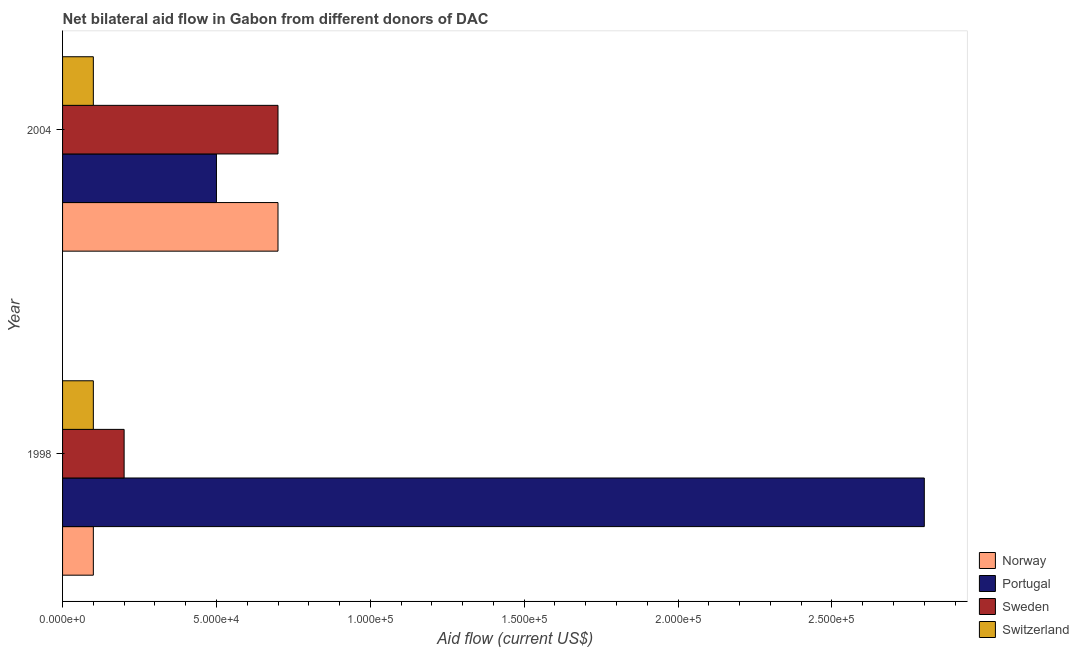How many different coloured bars are there?
Keep it short and to the point. 4. How many groups of bars are there?
Provide a short and direct response. 2. How many bars are there on the 1st tick from the top?
Your answer should be very brief. 4. What is the label of the 1st group of bars from the top?
Keep it short and to the point. 2004. In how many cases, is the number of bars for a given year not equal to the number of legend labels?
Provide a succinct answer. 0. What is the amount of aid given by portugal in 1998?
Make the answer very short. 2.80e+05. Across all years, what is the maximum amount of aid given by portugal?
Provide a succinct answer. 2.80e+05. Across all years, what is the minimum amount of aid given by sweden?
Your response must be concise. 2.00e+04. In which year was the amount of aid given by norway maximum?
Your response must be concise. 2004. What is the total amount of aid given by sweden in the graph?
Your answer should be very brief. 9.00e+04. What is the difference between the amount of aid given by sweden in 1998 and that in 2004?
Offer a terse response. -5.00e+04. What is the difference between the amount of aid given by portugal in 2004 and the amount of aid given by switzerland in 1998?
Provide a succinct answer. 4.00e+04. What is the average amount of aid given by sweden per year?
Provide a succinct answer. 4.50e+04. In the year 1998, what is the difference between the amount of aid given by sweden and amount of aid given by switzerland?
Offer a very short reply. 10000. What is the ratio of the amount of aid given by sweden in 1998 to that in 2004?
Keep it short and to the point. 0.29. Is it the case that in every year, the sum of the amount of aid given by portugal and amount of aid given by sweden is greater than the sum of amount of aid given by switzerland and amount of aid given by norway?
Offer a terse response. Yes. What does the 4th bar from the bottom in 2004 represents?
Make the answer very short. Switzerland. Is it the case that in every year, the sum of the amount of aid given by norway and amount of aid given by portugal is greater than the amount of aid given by sweden?
Make the answer very short. Yes. How many bars are there?
Keep it short and to the point. 8. Are all the bars in the graph horizontal?
Ensure brevity in your answer.  Yes. How many years are there in the graph?
Provide a short and direct response. 2. What is the difference between two consecutive major ticks on the X-axis?
Keep it short and to the point. 5.00e+04. Where does the legend appear in the graph?
Offer a terse response. Bottom right. What is the title of the graph?
Offer a terse response. Net bilateral aid flow in Gabon from different donors of DAC. Does "Services" appear as one of the legend labels in the graph?
Keep it short and to the point. No. What is the Aid flow (current US$) in Norway in 1998?
Provide a succinct answer. 10000. What is the Aid flow (current US$) of Portugal in 1998?
Ensure brevity in your answer.  2.80e+05. What is the Aid flow (current US$) in Sweden in 1998?
Give a very brief answer. 2.00e+04. What is the Aid flow (current US$) in Switzerland in 1998?
Keep it short and to the point. 10000. What is the Aid flow (current US$) in Norway in 2004?
Your response must be concise. 7.00e+04. What is the Aid flow (current US$) of Portugal in 2004?
Give a very brief answer. 5.00e+04. What is the Aid flow (current US$) of Sweden in 2004?
Offer a terse response. 7.00e+04. Across all years, what is the minimum Aid flow (current US$) of Sweden?
Make the answer very short. 2.00e+04. What is the total Aid flow (current US$) in Portugal in the graph?
Your response must be concise. 3.30e+05. What is the total Aid flow (current US$) in Sweden in the graph?
Ensure brevity in your answer.  9.00e+04. What is the total Aid flow (current US$) in Switzerland in the graph?
Ensure brevity in your answer.  2.00e+04. What is the difference between the Aid flow (current US$) of Norway in 1998 and that in 2004?
Your answer should be very brief. -6.00e+04. What is the difference between the Aid flow (current US$) of Sweden in 1998 and the Aid flow (current US$) of Switzerland in 2004?
Provide a succinct answer. 10000. What is the average Aid flow (current US$) of Norway per year?
Offer a very short reply. 4.00e+04. What is the average Aid flow (current US$) in Portugal per year?
Make the answer very short. 1.65e+05. What is the average Aid flow (current US$) of Sweden per year?
Give a very brief answer. 4.50e+04. What is the average Aid flow (current US$) in Switzerland per year?
Provide a succinct answer. 10000. In the year 2004, what is the difference between the Aid flow (current US$) of Norway and Aid flow (current US$) of Switzerland?
Keep it short and to the point. 6.00e+04. In the year 2004, what is the difference between the Aid flow (current US$) in Portugal and Aid flow (current US$) in Switzerland?
Provide a short and direct response. 4.00e+04. In the year 2004, what is the difference between the Aid flow (current US$) of Sweden and Aid flow (current US$) of Switzerland?
Your answer should be compact. 6.00e+04. What is the ratio of the Aid flow (current US$) in Norway in 1998 to that in 2004?
Offer a terse response. 0.14. What is the ratio of the Aid flow (current US$) of Sweden in 1998 to that in 2004?
Your response must be concise. 0.29. What is the difference between the highest and the second highest Aid flow (current US$) in Norway?
Your answer should be very brief. 6.00e+04. What is the difference between the highest and the second highest Aid flow (current US$) of Sweden?
Give a very brief answer. 5.00e+04. What is the difference between the highest and the second highest Aid flow (current US$) in Switzerland?
Make the answer very short. 0. What is the difference between the highest and the lowest Aid flow (current US$) of Norway?
Offer a very short reply. 6.00e+04. What is the difference between the highest and the lowest Aid flow (current US$) of Portugal?
Your answer should be compact. 2.30e+05. What is the difference between the highest and the lowest Aid flow (current US$) of Switzerland?
Keep it short and to the point. 0. 